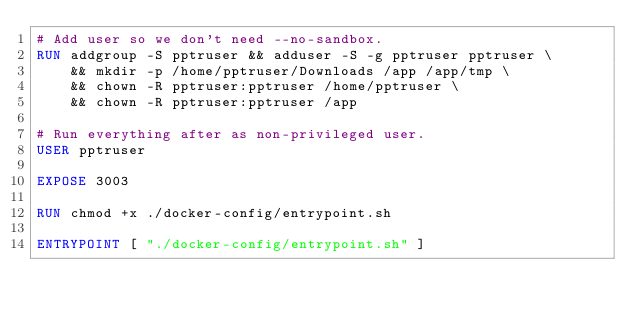Convert code to text. <code><loc_0><loc_0><loc_500><loc_500><_Dockerfile_># Add user so we don't need --no-sandbox.
RUN addgroup -S pptruser && adduser -S -g pptruser pptruser \
    && mkdir -p /home/pptruser/Downloads /app /app/tmp \
    && chown -R pptruser:pptruser /home/pptruser \
    && chown -R pptruser:pptruser /app

# Run everything after as non-privileged user.
USER pptruser

EXPOSE 3003

RUN chmod +x ./docker-config/entrypoint.sh

ENTRYPOINT [ "./docker-config/entrypoint.sh" ]
</code> 